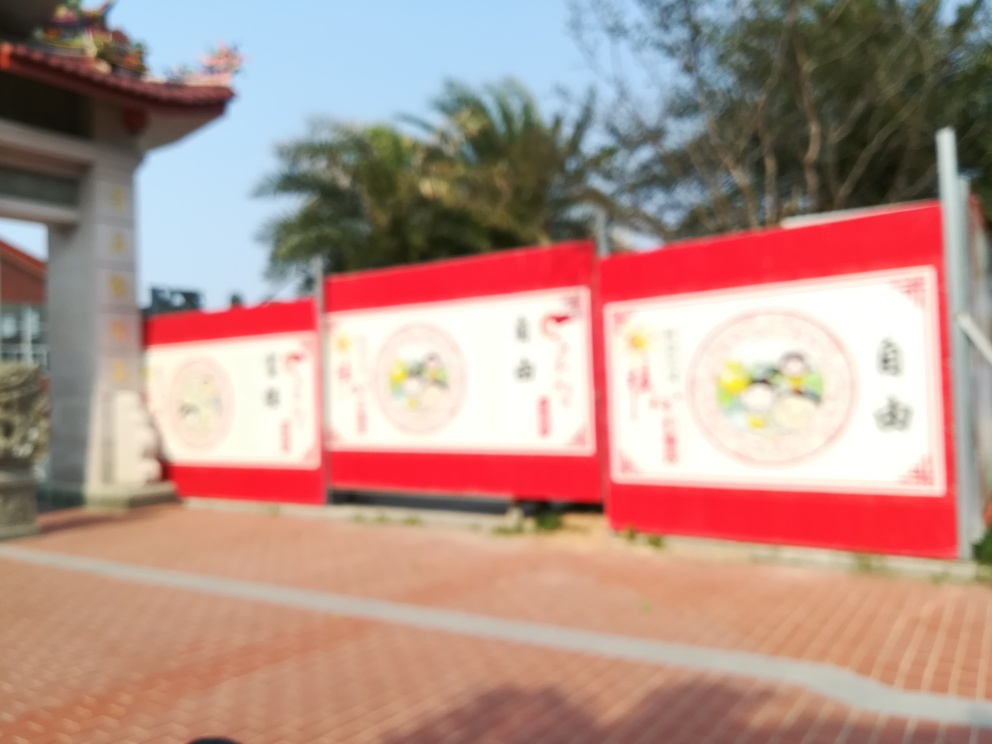Is the advertising billboard in focus? The image shows an advertising billboard that is not in focus. This artistic choice can draw attention to the environment around the billboard or create a certain mood or atmosphere. 